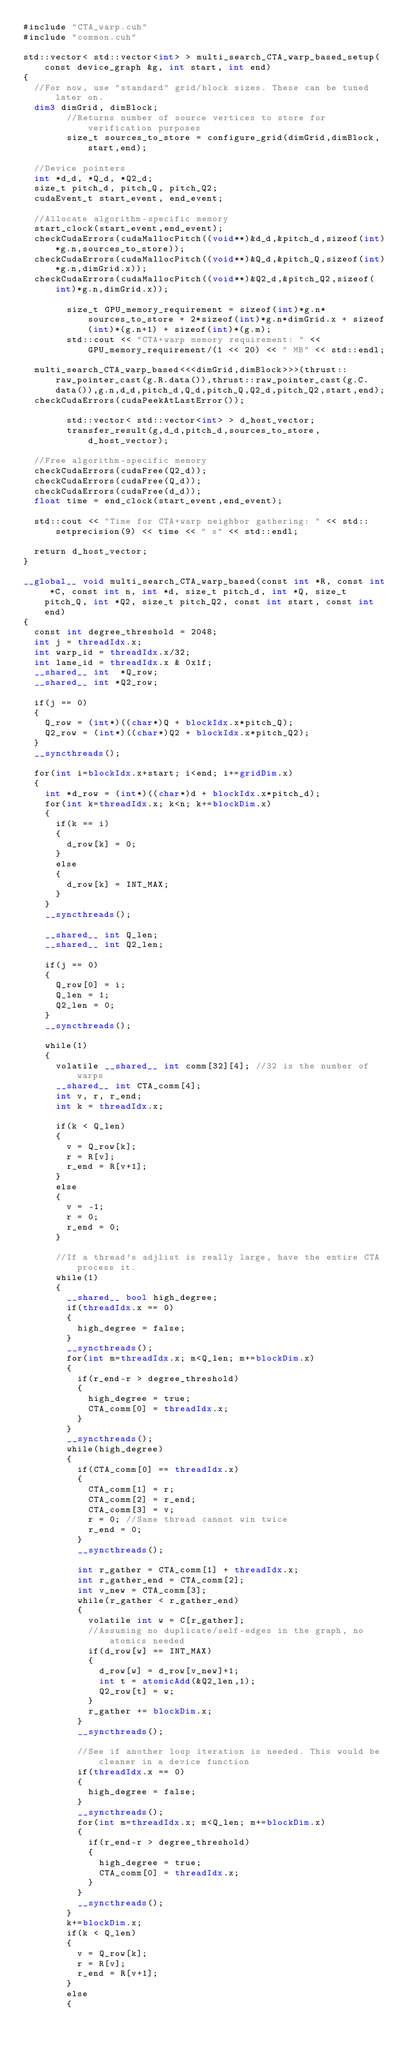<code> <loc_0><loc_0><loc_500><loc_500><_Cuda_>#include "CTA_warp.cuh"
#include "common.cuh"

std::vector< std::vector<int> > multi_search_CTA_warp_based_setup(const device_graph &g, int start, int end)
{
	//For now, use "standard" grid/block sizes. These can be tuned later on.
	dim3 dimGrid, dimBlock;
        //Returns number of source vertices to store for verification purposes
        size_t sources_to_store = configure_grid(dimGrid,dimBlock,start,end);

	//Device pointers
	int *d_d, *Q_d, *Q2_d;
	size_t pitch_d, pitch_Q, pitch_Q2;
	cudaEvent_t start_event, end_event;

	//Allocate algorithm-specific memory
	start_clock(start_event,end_event);
	checkCudaErrors(cudaMallocPitch((void**)&d_d,&pitch_d,sizeof(int)*g.n,sources_to_store));
	checkCudaErrors(cudaMallocPitch((void**)&Q_d,&pitch_Q,sizeof(int)*g.n,dimGrid.x));
	checkCudaErrors(cudaMallocPitch((void**)&Q2_d,&pitch_Q2,sizeof(int)*g.n,dimGrid.x));

        size_t GPU_memory_requirement = sizeof(int)*g.n*sources_to_store + 2*sizeof(int)*g.n*dimGrid.x + sizeof(int)*(g.n+1) + sizeof(int)*(g.m);
        std::cout << "CTA+warp memory requirement: " << GPU_memory_requirement/(1 << 20) << " MB" << std::endl;

	multi_search_CTA_warp_based<<<dimGrid,dimBlock>>>(thrust::raw_pointer_cast(g.R.data()),thrust::raw_pointer_cast(g.C.data()),g.n,d_d,pitch_d,Q_d,pitch_Q,Q2_d,pitch_Q2,start,end);
	checkCudaErrors(cudaPeekAtLastError());

        std::vector< std::vector<int> > d_host_vector;
        transfer_result(g,d_d,pitch_d,sources_to_store,d_host_vector);

	//Free algorithm-specific memory
	checkCudaErrors(cudaFree(Q2_d));
	checkCudaErrors(cudaFree(Q_d));
	checkCudaErrors(cudaFree(d_d));
	float time = end_clock(start_event,end_event);

	std::cout << "Time for CTA+warp neighbor gathering: " << std::setprecision(9) << time << " s" << std::endl;

	return d_host_vector;
}

__global__ void multi_search_CTA_warp_based(const int *R, const int *C, const int n, int *d, size_t pitch_d, int *Q, size_t pitch_Q, int *Q2, size_t pitch_Q2, const int start, const int end)
{
	const int degree_threshold = 2048;
	int j = threadIdx.x;
	int warp_id = threadIdx.x/32;
	int lane_id = threadIdx.x & 0x1f;
	__shared__ int  *Q_row;
	__shared__ int *Q2_row;

	if(j == 0)
	{
		Q_row = (int*)((char*)Q + blockIdx.x*pitch_Q);
		Q2_row = (int*)((char*)Q2 + blockIdx.x*pitch_Q2);
	}
	__syncthreads();

	for(int i=blockIdx.x+start; i<end; i+=gridDim.x)
	{
		int *d_row = (int*)((char*)d + blockIdx.x*pitch_d);
		for(int k=threadIdx.x; k<n; k+=blockDim.x)
		{
			if(k == i)
			{
				d_row[k] = 0;
			}
			else
			{
				d_row[k] = INT_MAX;
			}
		}
		__syncthreads();

		__shared__ int Q_len;
		__shared__ int Q2_len;

		if(j == 0)
		{
			Q_row[0] = i;
			Q_len = 1;
			Q2_len = 0;
		}
		__syncthreads();

		while(1)
		{
			volatile __shared__ int comm[32][4]; //32 is the number of warps
			__shared__ int CTA_comm[4];
			int v, r, r_end;	
			int k = threadIdx.x;

			if(k < Q_len)
			{	
				v = Q_row[k];
				r = R[v];
				r_end = R[v+1];
			}
			else
			{
				v = -1;
				r = 0;
				r_end = 0;
			}

			//If a thread's adjlist is really large, have the entire CTA process it. 
			while(1)
			{
				__shared__ bool high_degree;
				if(threadIdx.x == 0)
				{
					high_degree = false;
				}
				__syncthreads();
				for(int m=threadIdx.x; m<Q_len; m+=blockDim.x)
				{
					if(r_end-r > degree_threshold)
					{
						high_degree = true;
						CTA_comm[0] = threadIdx.x;
					}
				}
				__syncthreads();
				while(high_degree) 
				{
					if(CTA_comm[0] == threadIdx.x)
					{
						CTA_comm[1] = r;
						CTA_comm[2] = r_end;
						CTA_comm[3] = v;
						r = 0; //Same thread cannot win twice
						r_end = 0; 
					}
					__syncthreads();
					
					int r_gather = CTA_comm[1] + threadIdx.x;
					int r_gather_end = CTA_comm[2];
					int v_new = CTA_comm[3];
					while(r_gather < r_gather_end)
					{
						volatile int w = C[r_gather];
						//Assuming no duplicate/self-edges in the graph, no atomics needed
						if(d_row[w] == INT_MAX)
						{
							d_row[w] = d_row[v_new]+1;
							int t = atomicAdd(&Q2_len,1);
							Q2_row[t] = w;
						}
						r_gather += blockDim.x;
					}
					__syncthreads();
					
					//See if another loop iteration is needed. This would be cleaner in a device function
					if(threadIdx.x == 0)
					{
						high_degree = false;
					}
					__syncthreads();
					for(int m=threadIdx.x; m<Q_len; m+=blockDim.x)
					{
						if(r_end-r > degree_threshold)
						{
							high_degree = true;
							CTA_comm[0] = threadIdx.x;
						}
					}
					__syncthreads();
				}
				k+=blockDim.x;
				if(k < Q_len)
				{
					v = Q_row[k];
					r = R[v];
					r_end = R[v+1];
				}
				else
				{</code> 